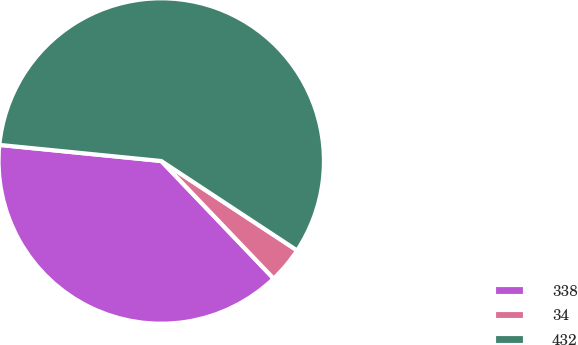<chart> <loc_0><loc_0><loc_500><loc_500><pie_chart><fcel>338<fcel>34<fcel>432<nl><fcel>38.72%<fcel>3.59%<fcel>57.69%<nl></chart> 